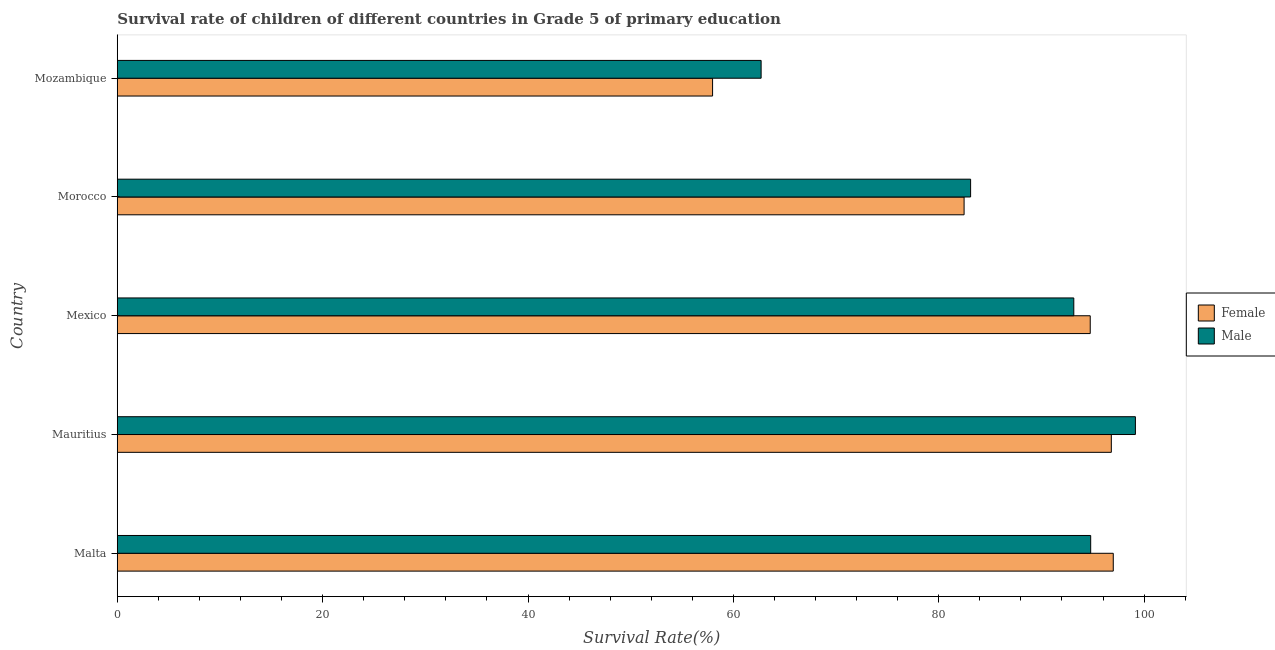How many different coloured bars are there?
Provide a succinct answer. 2. How many groups of bars are there?
Ensure brevity in your answer.  5. How many bars are there on the 5th tick from the bottom?
Provide a short and direct response. 2. What is the label of the 2nd group of bars from the top?
Offer a terse response. Morocco. What is the survival rate of female students in primary education in Morocco?
Offer a very short reply. 82.47. Across all countries, what is the maximum survival rate of female students in primary education?
Give a very brief answer. 97. Across all countries, what is the minimum survival rate of female students in primary education?
Your answer should be compact. 57.97. In which country was the survival rate of female students in primary education maximum?
Your response must be concise. Malta. In which country was the survival rate of female students in primary education minimum?
Give a very brief answer. Mozambique. What is the total survival rate of male students in primary education in the graph?
Provide a succinct answer. 432.9. What is the difference between the survival rate of male students in primary education in Malta and that in Mauritius?
Ensure brevity in your answer.  -4.36. What is the difference between the survival rate of male students in primary education in Mexico and the survival rate of female students in primary education in Mauritius?
Make the answer very short. -3.65. What is the average survival rate of male students in primary education per country?
Keep it short and to the point. 86.58. What is the difference between the survival rate of male students in primary education and survival rate of female students in primary education in Mozambique?
Keep it short and to the point. 4.73. Is the difference between the survival rate of female students in primary education in Mauritius and Mexico greater than the difference between the survival rate of male students in primary education in Mauritius and Mexico?
Your response must be concise. No. What is the difference between the highest and the second highest survival rate of female students in primary education?
Your response must be concise. 0.19. What is the difference between the highest and the lowest survival rate of male students in primary education?
Your answer should be very brief. 36.45. What does the 2nd bar from the top in Malta represents?
Provide a short and direct response. Female. What does the 1st bar from the bottom in Mozambique represents?
Provide a short and direct response. Female. What is the difference between two consecutive major ticks on the X-axis?
Make the answer very short. 20. Are the values on the major ticks of X-axis written in scientific E-notation?
Your answer should be very brief. No. What is the title of the graph?
Your answer should be compact. Survival rate of children of different countries in Grade 5 of primary education. Does "All education staff compensation" appear as one of the legend labels in the graph?
Offer a very short reply. No. What is the label or title of the X-axis?
Your answer should be compact. Survival Rate(%). What is the Survival Rate(%) of Female in Malta?
Keep it short and to the point. 97. What is the Survival Rate(%) in Male in Malta?
Your answer should be very brief. 94.8. What is the Survival Rate(%) of Female in Mauritius?
Offer a very short reply. 96.81. What is the Survival Rate(%) of Male in Mauritius?
Make the answer very short. 99.15. What is the Survival Rate(%) in Female in Mexico?
Provide a short and direct response. 94.75. What is the Survival Rate(%) in Male in Mexico?
Your response must be concise. 93.15. What is the Survival Rate(%) of Female in Morocco?
Provide a short and direct response. 82.47. What is the Survival Rate(%) in Male in Morocco?
Ensure brevity in your answer.  83.1. What is the Survival Rate(%) of Female in Mozambique?
Offer a very short reply. 57.97. What is the Survival Rate(%) in Male in Mozambique?
Your response must be concise. 62.7. Across all countries, what is the maximum Survival Rate(%) of Female?
Make the answer very short. 97. Across all countries, what is the maximum Survival Rate(%) of Male?
Give a very brief answer. 99.15. Across all countries, what is the minimum Survival Rate(%) in Female?
Your response must be concise. 57.97. Across all countries, what is the minimum Survival Rate(%) in Male?
Make the answer very short. 62.7. What is the total Survival Rate(%) of Female in the graph?
Your answer should be compact. 429. What is the total Survival Rate(%) in Male in the graph?
Keep it short and to the point. 432.9. What is the difference between the Survival Rate(%) of Female in Malta and that in Mauritius?
Offer a terse response. 0.19. What is the difference between the Survival Rate(%) of Male in Malta and that in Mauritius?
Keep it short and to the point. -4.35. What is the difference between the Survival Rate(%) in Female in Malta and that in Mexico?
Ensure brevity in your answer.  2.24. What is the difference between the Survival Rate(%) in Male in Malta and that in Mexico?
Offer a terse response. 1.64. What is the difference between the Survival Rate(%) in Female in Malta and that in Morocco?
Offer a very short reply. 14.53. What is the difference between the Survival Rate(%) in Male in Malta and that in Morocco?
Ensure brevity in your answer.  11.69. What is the difference between the Survival Rate(%) of Female in Malta and that in Mozambique?
Keep it short and to the point. 39.02. What is the difference between the Survival Rate(%) of Male in Malta and that in Mozambique?
Give a very brief answer. 32.1. What is the difference between the Survival Rate(%) of Female in Mauritius and that in Mexico?
Offer a very short reply. 2.05. What is the difference between the Survival Rate(%) in Male in Mauritius and that in Mexico?
Make the answer very short. 6. What is the difference between the Survival Rate(%) of Female in Mauritius and that in Morocco?
Make the answer very short. 14.34. What is the difference between the Survival Rate(%) of Male in Mauritius and that in Morocco?
Give a very brief answer. 16.05. What is the difference between the Survival Rate(%) of Female in Mauritius and that in Mozambique?
Keep it short and to the point. 38.83. What is the difference between the Survival Rate(%) of Male in Mauritius and that in Mozambique?
Make the answer very short. 36.45. What is the difference between the Survival Rate(%) in Female in Mexico and that in Morocco?
Make the answer very short. 12.29. What is the difference between the Survival Rate(%) of Male in Mexico and that in Morocco?
Your answer should be very brief. 10.05. What is the difference between the Survival Rate(%) of Female in Mexico and that in Mozambique?
Your answer should be very brief. 36.78. What is the difference between the Survival Rate(%) in Male in Mexico and that in Mozambique?
Your answer should be compact. 30.45. What is the difference between the Survival Rate(%) of Female in Morocco and that in Mozambique?
Your answer should be compact. 24.49. What is the difference between the Survival Rate(%) of Male in Morocco and that in Mozambique?
Your answer should be very brief. 20.4. What is the difference between the Survival Rate(%) of Female in Malta and the Survival Rate(%) of Male in Mauritius?
Give a very brief answer. -2.15. What is the difference between the Survival Rate(%) in Female in Malta and the Survival Rate(%) in Male in Mexico?
Offer a terse response. 3.84. What is the difference between the Survival Rate(%) of Female in Malta and the Survival Rate(%) of Male in Morocco?
Your answer should be very brief. 13.89. What is the difference between the Survival Rate(%) of Female in Malta and the Survival Rate(%) of Male in Mozambique?
Your answer should be very brief. 34.3. What is the difference between the Survival Rate(%) of Female in Mauritius and the Survival Rate(%) of Male in Mexico?
Provide a short and direct response. 3.65. What is the difference between the Survival Rate(%) of Female in Mauritius and the Survival Rate(%) of Male in Morocco?
Give a very brief answer. 13.7. What is the difference between the Survival Rate(%) of Female in Mauritius and the Survival Rate(%) of Male in Mozambique?
Keep it short and to the point. 34.1. What is the difference between the Survival Rate(%) of Female in Mexico and the Survival Rate(%) of Male in Morocco?
Make the answer very short. 11.65. What is the difference between the Survival Rate(%) of Female in Mexico and the Survival Rate(%) of Male in Mozambique?
Offer a very short reply. 32.05. What is the difference between the Survival Rate(%) in Female in Morocco and the Survival Rate(%) in Male in Mozambique?
Your answer should be compact. 19.77. What is the average Survival Rate(%) in Female per country?
Keep it short and to the point. 85.8. What is the average Survival Rate(%) in Male per country?
Offer a terse response. 86.58. What is the difference between the Survival Rate(%) of Female and Survival Rate(%) of Male in Malta?
Your answer should be very brief. 2.2. What is the difference between the Survival Rate(%) in Female and Survival Rate(%) in Male in Mauritius?
Provide a short and direct response. -2.34. What is the difference between the Survival Rate(%) of Female and Survival Rate(%) of Male in Mexico?
Ensure brevity in your answer.  1.6. What is the difference between the Survival Rate(%) in Female and Survival Rate(%) in Male in Morocco?
Keep it short and to the point. -0.63. What is the difference between the Survival Rate(%) of Female and Survival Rate(%) of Male in Mozambique?
Keep it short and to the point. -4.73. What is the ratio of the Survival Rate(%) of Male in Malta to that in Mauritius?
Give a very brief answer. 0.96. What is the ratio of the Survival Rate(%) of Female in Malta to that in Mexico?
Your answer should be compact. 1.02. What is the ratio of the Survival Rate(%) of Male in Malta to that in Mexico?
Provide a succinct answer. 1.02. What is the ratio of the Survival Rate(%) of Female in Malta to that in Morocco?
Keep it short and to the point. 1.18. What is the ratio of the Survival Rate(%) of Male in Malta to that in Morocco?
Ensure brevity in your answer.  1.14. What is the ratio of the Survival Rate(%) in Female in Malta to that in Mozambique?
Your answer should be compact. 1.67. What is the ratio of the Survival Rate(%) of Male in Malta to that in Mozambique?
Your response must be concise. 1.51. What is the ratio of the Survival Rate(%) in Female in Mauritius to that in Mexico?
Ensure brevity in your answer.  1.02. What is the ratio of the Survival Rate(%) of Male in Mauritius to that in Mexico?
Give a very brief answer. 1.06. What is the ratio of the Survival Rate(%) in Female in Mauritius to that in Morocco?
Offer a terse response. 1.17. What is the ratio of the Survival Rate(%) in Male in Mauritius to that in Morocco?
Your response must be concise. 1.19. What is the ratio of the Survival Rate(%) in Female in Mauritius to that in Mozambique?
Give a very brief answer. 1.67. What is the ratio of the Survival Rate(%) of Male in Mauritius to that in Mozambique?
Offer a very short reply. 1.58. What is the ratio of the Survival Rate(%) of Female in Mexico to that in Morocco?
Ensure brevity in your answer.  1.15. What is the ratio of the Survival Rate(%) in Male in Mexico to that in Morocco?
Make the answer very short. 1.12. What is the ratio of the Survival Rate(%) of Female in Mexico to that in Mozambique?
Ensure brevity in your answer.  1.63. What is the ratio of the Survival Rate(%) of Male in Mexico to that in Mozambique?
Give a very brief answer. 1.49. What is the ratio of the Survival Rate(%) of Female in Morocco to that in Mozambique?
Ensure brevity in your answer.  1.42. What is the ratio of the Survival Rate(%) in Male in Morocco to that in Mozambique?
Make the answer very short. 1.33. What is the difference between the highest and the second highest Survival Rate(%) in Female?
Offer a very short reply. 0.19. What is the difference between the highest and the second highest Survival Rate(%) of Male?
Give a very brief answer. 4.35. What is the difference between the highest and the lowest Survival Rate(%) in Female?
Your answer should be very brief. 39.02. What is the difference between the highest and the lowest Survival Rate(%) in Male?
Offer a terse response. 36.45. 